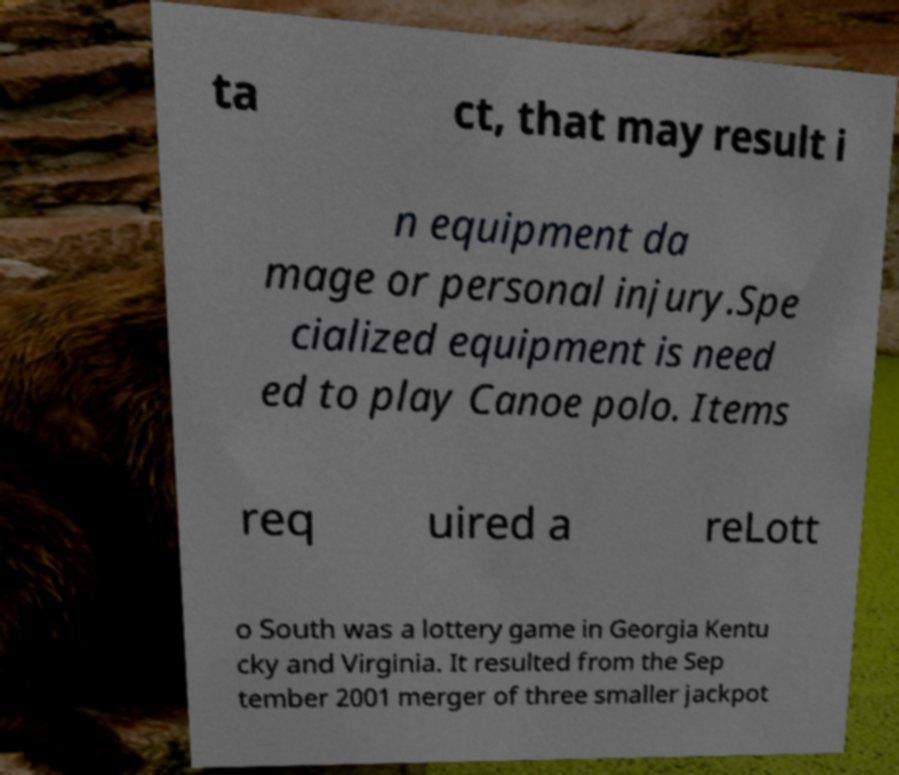I need the written content from this picture converted into text. Can you do that? ta ct, that may result i n equipment da mage or personal injury.Spe cialized equipment is need ed to play Canoe polo. Items req uired a reLott o South was a lottery game in Georgia Kentu cky and Virginia. It resulted from the Sep tember 2001 merger of three smaller jackpot 